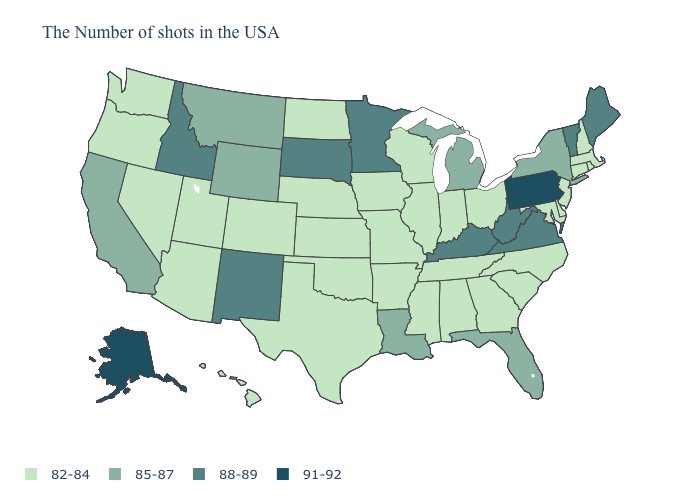Which states have the lowest value in the Northeast?
Write a very short answer. Massachusetts, Rhode Island, New Hampshire, Connecticut, New Jersey. Which states have the lowest value in the MidWest?
Concise answer only. Ohio, Indiana, Wisconsin, Illinois, Missouri, Iowa, Kansas, Nebraska, North Dakota. Among the states that border Ohio , does Pennsylvania have the lowest value?
Be succinct. No. What is the value of New Jersey?
Be succinct. 82-84. Which states have the lowest value in the South?
Answer briefly. Delaware, Maryland, North Carolina, South Carolina, Georgia, Alabama, Tennessee, Mississippi, Arkansas, Oklahoma, Texas. What is the highest value in the USA?
Give a very brief answer. 91-92. What is the value of Maryland?
Give a very brief answer. 82-84. Does New Jersey have the same value as South Dakota?
Answer briefly. No. What is the value of South Carolina?
Be succinct. 82-84. Name the states that have a value in the range 85-87?
Write a very short answer. New York, Florida, Michigan, Louisiana, Wyoming, Montana, California. Name the states that have a value in the range 85-87?
Keep it brief. New York, Florida, Michigan, Louisiana, Wyoming, Montana, California. Does Michigan have the lowest value in the MidWest?
Write a very short answer. No. Which states have the highest value in the USA?
Give a very brief answer. Pennsylvania, Alaska. Does South Dakota have the highest value in the MidWest?
Short answer required. Yes. Does the map have missing data?
Write a very short answer. No. 